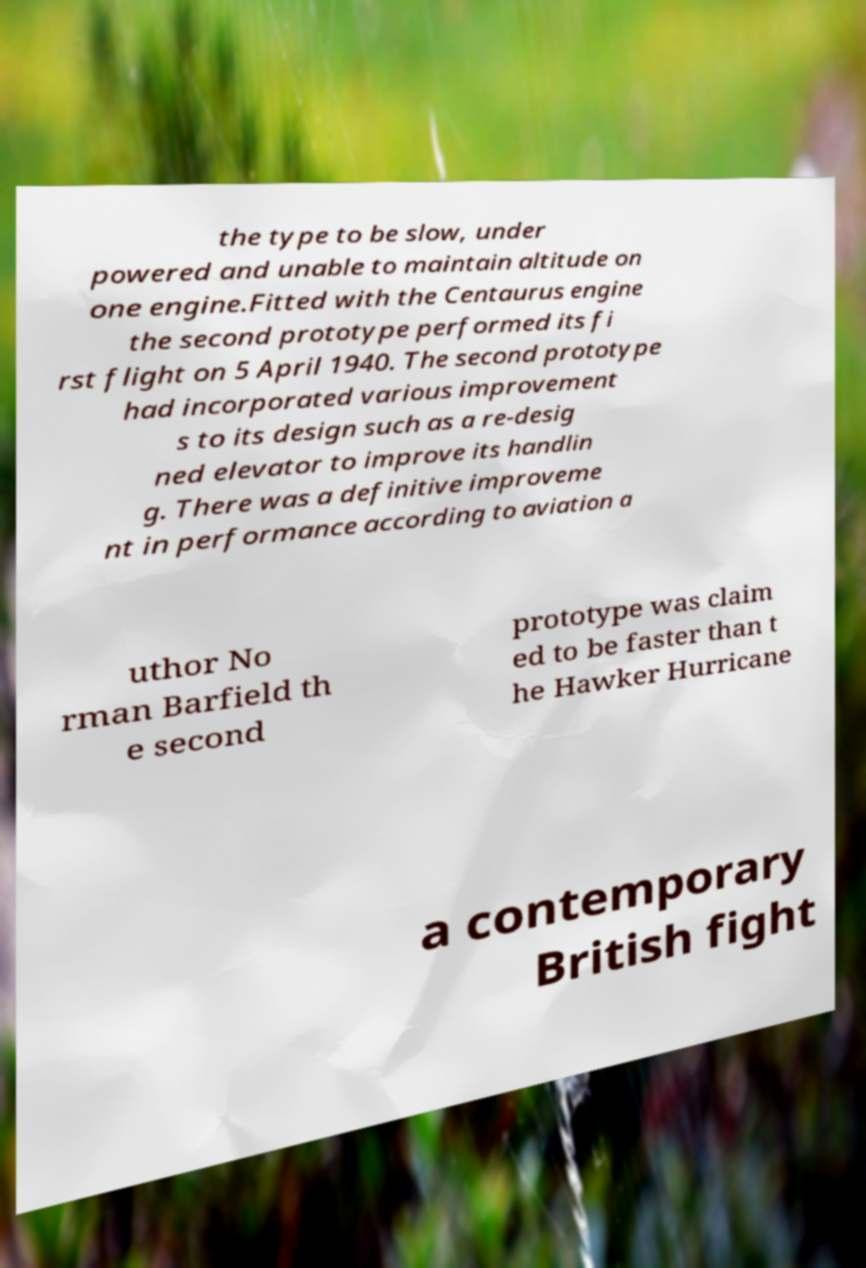There's text embedded in this image that I need extracted. Can you transcribe it verbatim? the type to be slow, under powered and unable to maintain altitude on one engine.Fitted with the Centaurus engine the second prototype performed its fi rst flight on 5 April 1940. The second prototype had incorporated various improvement s to its design such as a re-desig ned elevator to improve its handlin g. There was a definitive improveme nt in performance according to aviation a uthor No rman Barfield th e second prototype was claim ed to be faster than t he Hawker Hurricane a contemporary British fight 